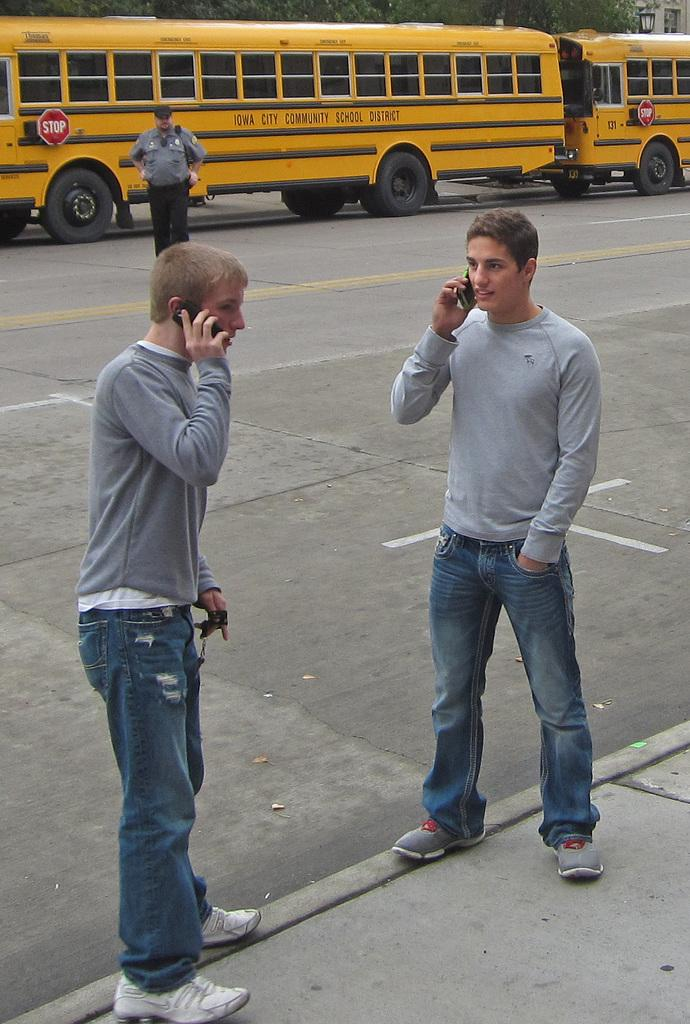How many people are in the image? There are three persons in the image. What are two of the persons doing with their hands? Two of the persons are holding mobile phones. What else can be seen in the image besides the people? There are vehicles, trees, light, and a building visible in the image. What type of attraction can be seen in the image? There is no attraction present in the image; it features three people, vehicles, trees, light, and a building. What type of work are the people in the image engaged in? The image does not provide any information about the work or occupation of the people. 